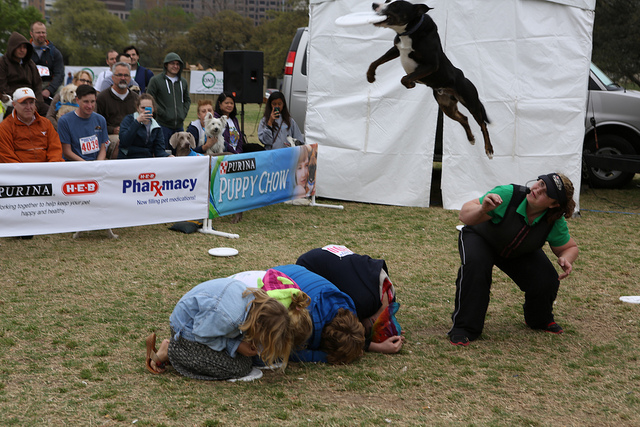Identify the text displayed in this image. PURINA PhaRmacy PUPPY CHOW PURINA 4035 H.E.B 